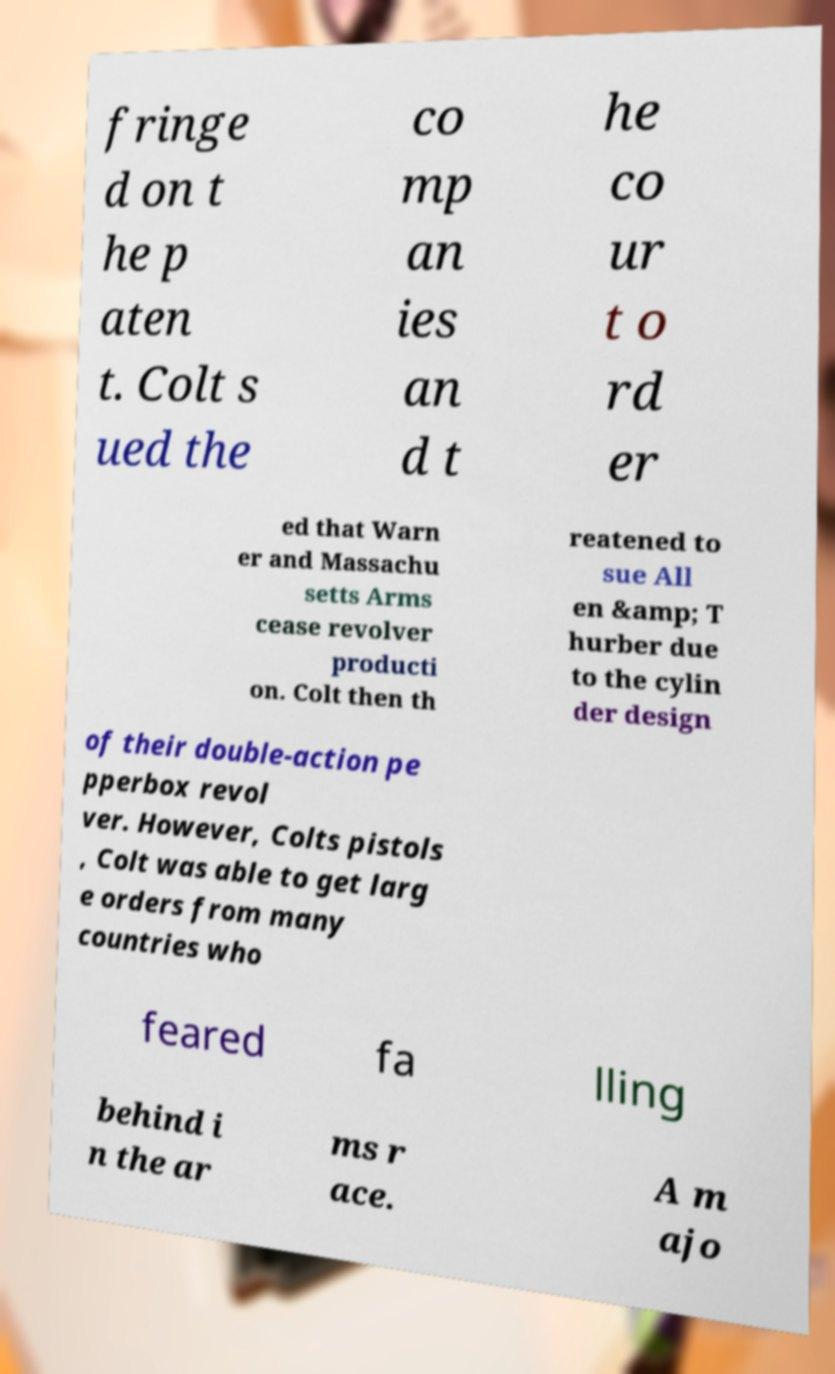Can you accurately transcribe the text from the provided image for me? fringe d on t he p aten t. Colt s ued the co mp an ies an d t he co ur t o rd er ed that Warn er and Massachu setts Arms cease revolver producti on. Colt then th reatened to sue All en &amp; T hurber due to the cylin der design of their double-action pe pperbox revol ver. However, Colts pistols , Colt was able to get larg e orders from many countries who feared fa lling behind i n the ar ms r ace. A m ajo 